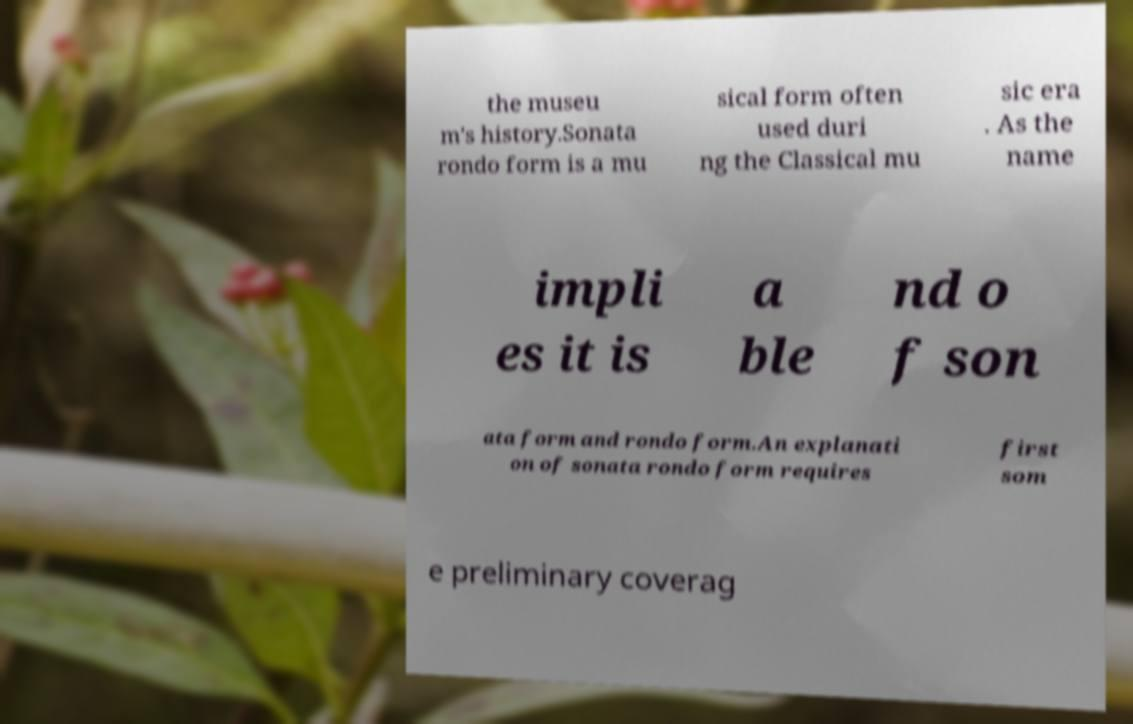There's text embedded in this image that I need extracted. Can you transcribe it verbatim? the museu m's history.Sonata rondo form is a mu sical form often used duri ng the Classical mu sic era . As the name impli es it is a ble nd o f son ata form and rondo form.An explanati on of sonata rondo form requires first som e preliminary coverag 